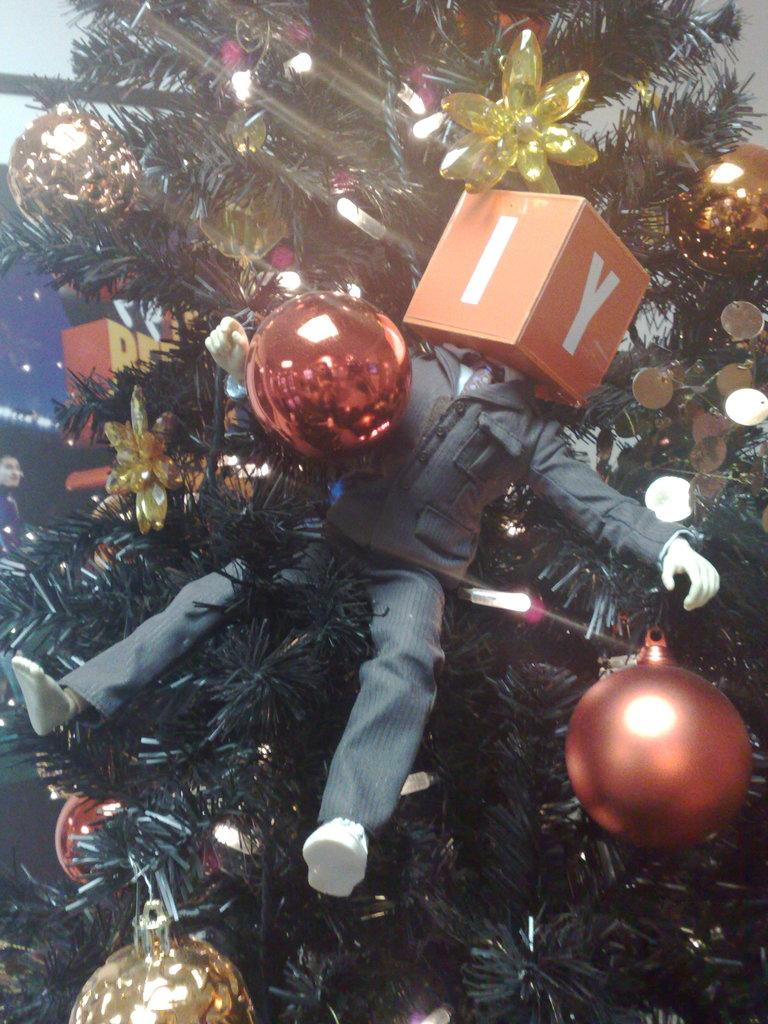What is the main feature of the tree in the image? The tree is decorated with lights in the image. What can be found on the tree besides lights? There are objects and a toy on the tree. Can you describe the person on the left side of the image? Unfortunately, the facts provided do not give any information about the person's appearance or actions. What type of sail can be seen on the tree in the image? There is no sail present in the image; the tree is decorated with lights and objects, including a toy. 